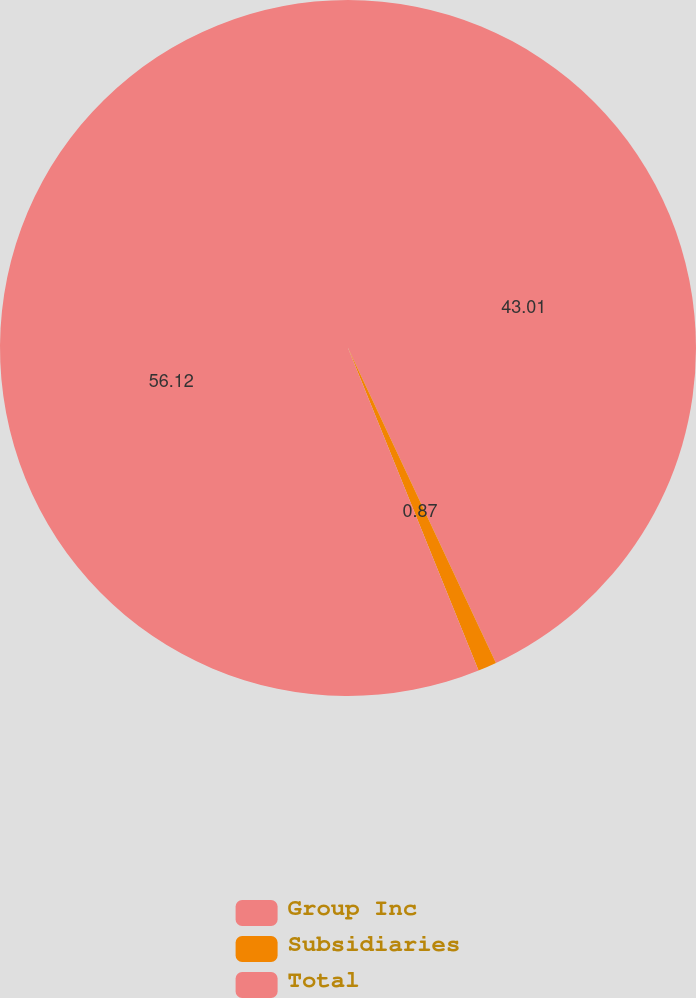<chart> <loc_0><loc_0><loc_500><loc_500><pie_chart><fcel>Group Inc<fcel>Subsidiaries<fcel>Total<nl><fcel>43.01%<fcel>0.87%<fcel>56.12%<nl></chart> 